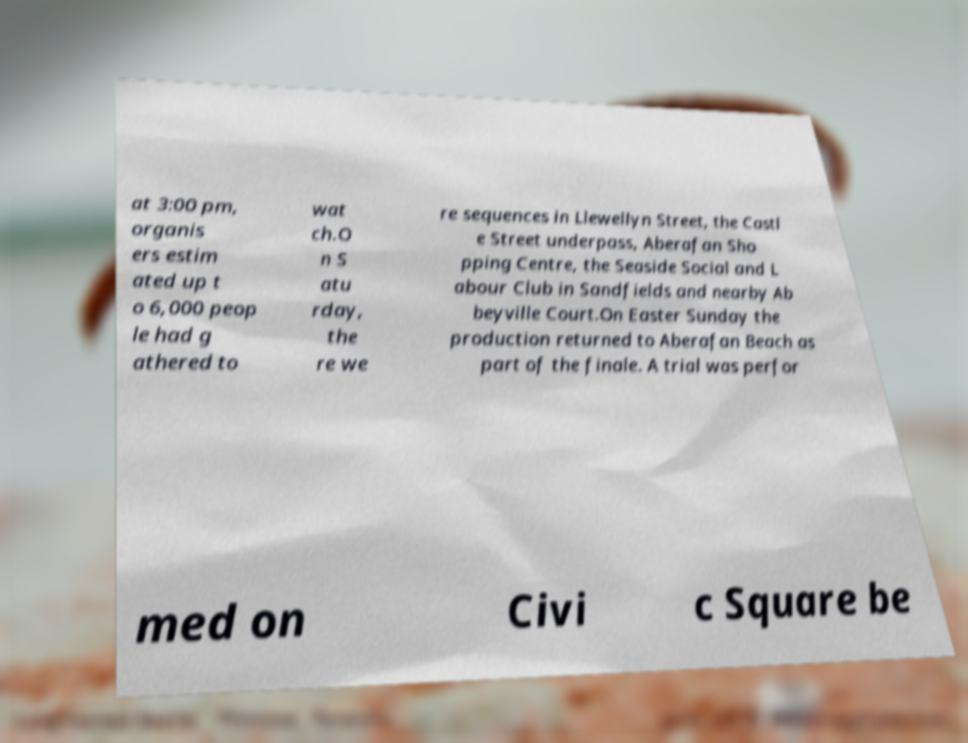There's text embedded in this image that I need extracted. Can you transcribe it verbatim? at 3:00 pm, organis ers estim ated up t o 6,000 peop le had g athered to wat ch.O n S atu rday, the re we re sequences in Llewellyn Street, the Castl e Street underpass, Aberafan Sho pping Centre, the Seaside Social and L abour Club in Sandfields and nearby Ab beyville Court.On Easter Sunday the production returned to Aberafan Beach as part of the finale. A trial was perfor med on Civi c Square be 